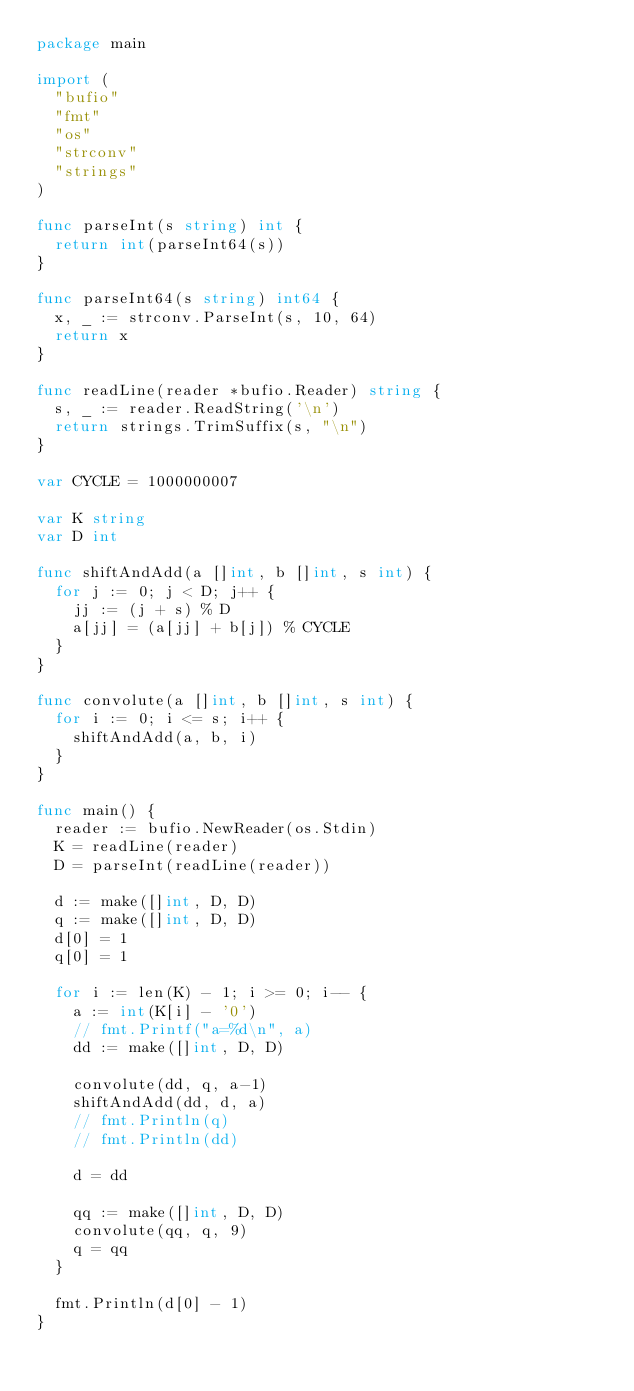<code> <loc_0><loc_0><loc_500><loc_500><_Go_>package main

import (
	"bufio"
	"fmt"
	"os"
	"strconv"
	"strings"
)

func parseInt(s string) int {
	return int(parseInt64(s))
}

func parseInt64(s string) int64 {
	x, _ := strconv.ParseInt(s, 10, 64)
	return x
}

func readLine(reader *bufio.Reader) string {
	s, _ := reader.ReadString('\n')
	return strings.TrimSuffix(s, "\n")
}

var CYCLE = 1000000007

var K string
var D int

func shiftAndAdd(a []int, b []int, s int) {
	for j := 0; j < D; j++ {
		jj := (j + s) % D
		a[jj] = (a[jj] + b[j]) % CYCLE
	}
}

func convolute(a []int, b []int, s int) {
	for i := 0; i <= s; i++ {
		shiftAndAdd(a, b, i)
	}
}

func main() {
	reader := bufio.NewReader(os.Stdin)
	K = readLine(reader)
	D = parseInt(readLine(reader))

	d := make([]int, D, D)
	q := make([]int, D, D)
	d[0] = 1
	q[0] = 1

	for i := len(K) - 1; i >= 0; i-- {
		a := int(K[i] - '0')
		// fmt.Printf("a=%d\n", a)
		dd := make([]int, D, D)

		convolute(dd, q, a-1)
		shiftAndAdd(dd, d, a)
		// fmt.Println(q)
		// fmt.Println(dd)

		d = dd

		qq := make([]int, D, D)
		convolute(qq, q, 9)
		q = qq
	}

	fmt.Println(d[0] - 1)
}
</code> 